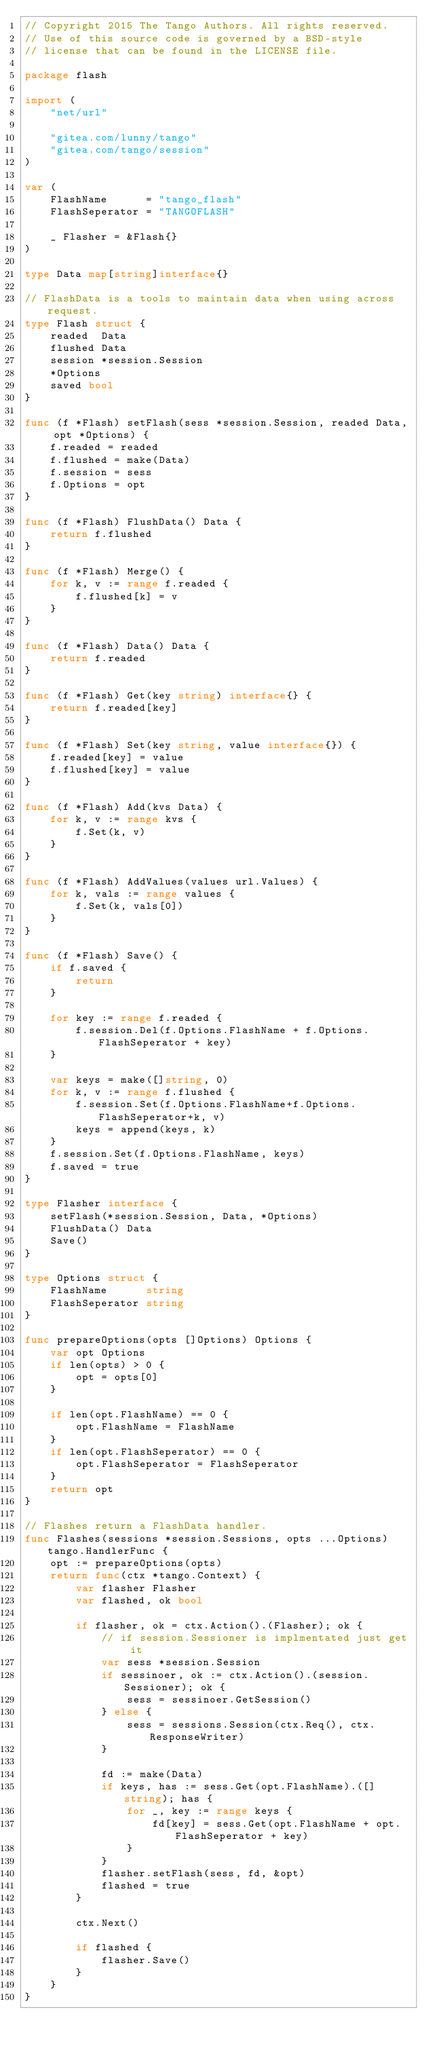Convert code to text. <code><loc_0><loc_0><loc_500><loc_500><_Go_>// Copyright 2015 The Tango Authors. All rights reserved.
// Use of this source code is governed by a BSD-style
// license that can be found in the LICENSE file.

package flash

import (
	"net/url"

	"gitea.com/lunny/tango"
	"gitea.com/tango/session"
)

var (
	FlashName      = "tango_flash"
	FlashSeperator = "TANGOFLASH"

	_ Flasher = &Flash{}
)

type Data map[string]interface{}

// FlashData is a tools to maintain data when using across request.
type Flash struct {
	readed  Data
	flushed Data
	session *session.Session
	*Options
	saved bool
}

func (f *Flash) setFlash(sess *session.Session, readed Data, opt *Options) {
	f.readed = readed
	f.flushed = make(Data)
	f.session = sess
	f.Options = opt
}

func (f *Flash) FlushData() Data {
	return f.flushed
}

func (f *Flash) Merge() {
	for k, v := range f.readed {
		f.flushed[k] = v
	}
}

func (f *Flash) Data() Data {
	return f.readed
}

func (f *Flash) Get(key string) interface{} {
	return f.readed[key]
}

func (f *Flash) Set(key string, value interface{}) {
	f.readed[key] = value
	f.flushed[key] = value
}

func (f *Flash) Add(kvs Data) {
	for k, v := range kvs {
		f.Set(k, v)
	}
}

func (f *Flash) AddValues(values url.Values) {
	for k, vals := range values {
		f.Set(k, vals[0])
	}
}

func (f *Flash) Save() {
	if f.saved {
		return
	}

	for key := range f.readed {
		f.session.Del(f.Options.FlashName + f.Options.FlashSeperator + key)
	}

	var keys = make([]string, 0)
	for k, v := range f.flushed {
		f.session.Set(f.Options.FlashName+f.Options.FlashSeperator+k, v)
		keys = append(keys, k)
	}
	f.session.Set(f.Options.FlashName, keys)
	f.saved = true
}

type Flasher interface {
	setFlash(*session.Session, Data, *Options)
	FlushData() Data
	Save()
}

type Options struct {
	FlashName      string
	FlashSeperator string
}

func prepareOptions(opts []Options) Options {
	var opt Options
	if len(opts) > 0 {
		opt = opts[0]
	}

	if len(opt.FlashName) == 0 {
		opt.FlashName = FlashName
	}
	if len(opt.FlashSeperator) == 0 {
		opt.FlashSeperator = FlashSeperator
	}
	return opt
}

// Flashes return a FlashData handler.
func Flashes(sessions *session.Sessions, opts ...Options) tango.HandlerFunc {
	opt := prepareOptions(opts)
	return func(ctx *tango.Context) {
		var flasher Flasher
		var flashed, ok bool

		if flasher, ok = ctx.Action().(Flasher); ok {
			// if session.Sessioner is implmentated just get it
			var sess *session.Session
			if sessinoer, ok := ctx.Action().(session.Sessioner); ok {
				sess = sessinoer.GetSession()
			} else {
				sess = sessions.Session(ctx.Req(), ctx.ResponseWriter)
			}

			fd := make(Data)
			if keys, has := sess.Get(opt.FlashName).([]string); has {
				for _, key := range keys {
					fd[key] = sess.Get(opt.FlashName + opt.FlashSeperator + key)
				}
			}
			flasher.setFlash(sess, fd, &opt)
			flashed = true
		}

		ctx.Next()

		if flashed {
			flasher.Save()
		}
	}
}
</code> 